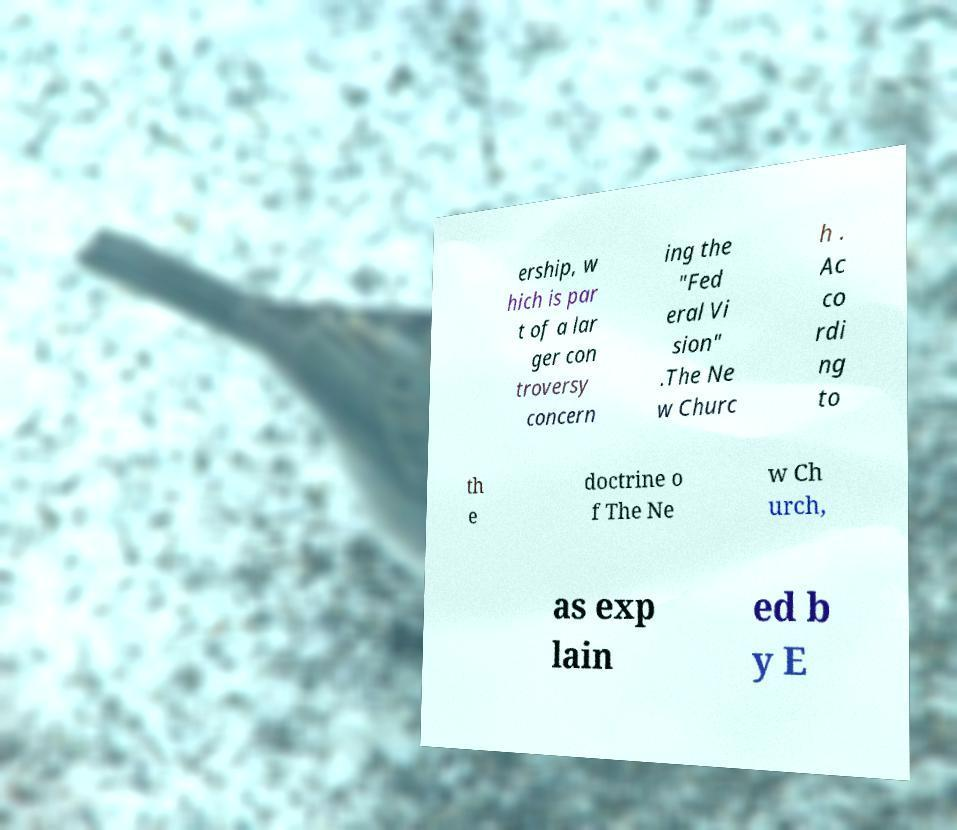I need the written content from this picture converted into text. Can you do that? ership, w hich is par t of a lar ger con troversy concern ing the "Fed eral Vi sion" .The Ne w Churc h . Ac co rdi ng to th e doctrine o f The Ne w Ch urch, as exp lain ed b y E 